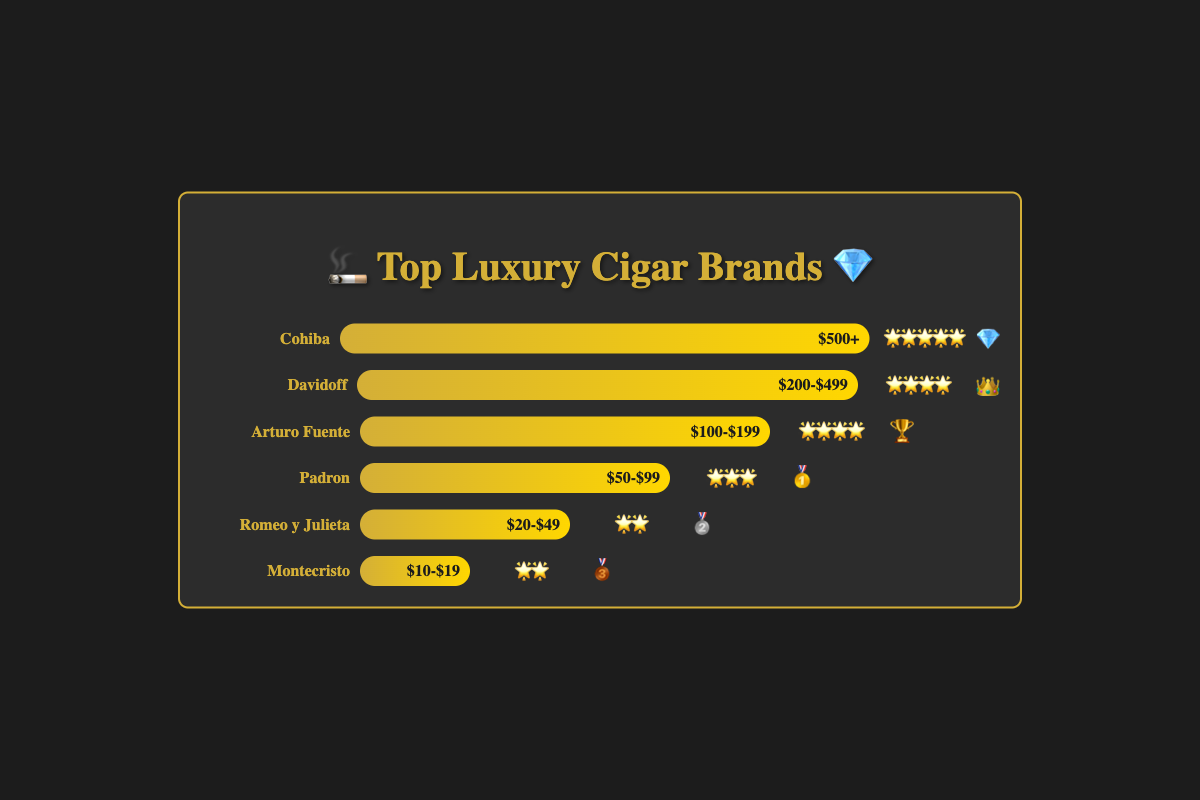Which cigar brand has the highest luxury rating? The highest luxury rating of 🌟🌟🌟🌟🌟 is assigned to the cigar brand Cohiba.
Answer: Cohiba What is the price range of Montecristo? Montecristo has a price range of $10-$19, as shown in its bar fill section.
Answer: $10-$19 How many cigar brands have a luxury rating of 🌟🌟? Two cigar brands, Montecristo and Romeo y Julieta, have a luxury rating of 🌟🌟.
Answer: 2 Which cigar brand is associated with the emoji 👑? The cigar brand Davidoff is associated with the emoji 👑, as seen in the bar for Davidoff.
Answer: Davidoff What is the luxury rating of Arturo Fuente? The luxury rating of Arturo Fuente is 🌟🌟🌟🌟 as indicated by the stars in its corresponding section.
Answer: 🌟🌟🌟🌟 Compare the luxury ratings of Padron and Romeo y Julieta. Which one is higher? Padron has a luxury rating of 🌟🌟🌟, while Romeo y Julieta has a luxury rating of 🌟🌟. Therefore, Padron has the higher luxury rating.
Answer: Padron How many brands have a price range below $50? Three brands, Romeo y Julieta, Montecristo, and Padron, have a price range below $50.
Answer: 3 Which brand is represented by the 🥇 emoji, and what is its price range? The brand represented by the 🥇 emoji is Padron, which has a price range of $50-$99.
Answer: Padron, $50-$99 What is the average luxury rating (in stars) for cigar brands with a price range of $100-$199? Arturo Fuente is the only brand in the $100-$199 price range, with a luxury rating of 🌟🌟🌟🌟. Thus, the average luxury rating is 4 stars.
Answer: 4 